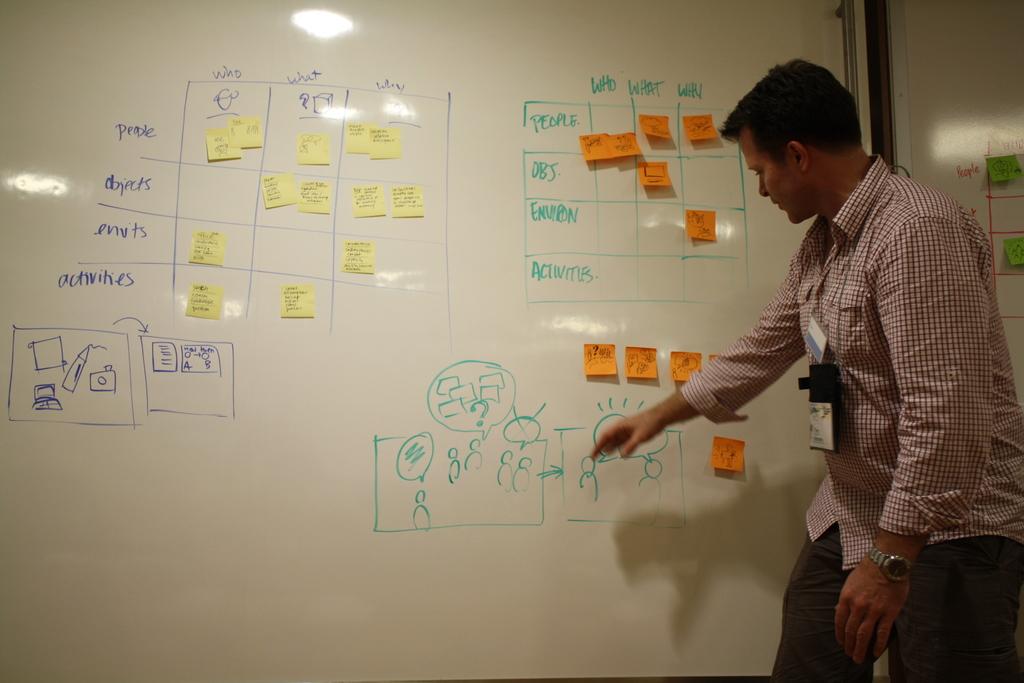What is the first column in both charts?
Make the answer very short. Who. What is written in the top of the blue column on the right?
Your response must be concise. Who. 